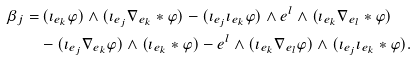<formula> <loc_0><loc_0><loc_500><loc_500>\beta _ { j } = & \, ( \imath _ { e _ { k } } \varphi ) \wedge ( \imath _ { e _ { j } } \nabla _ { e _ { k } } \ast \varphi ) - ( \imath _ { e _ { j } } \imath _ { e _ { k } } \varphi ) \wedge e ^ { l } \wedge ( \imath _ { e _ { k } } \nabla _ { e _ { l } } \ast \varphi ) \\ & - ( \imath _ { e _ { j } } \nabla _ { e _ { k } } \varphi ) \wedge ( \imath _ { e _ { k } } \ast \varphi ) - e ^ { l } \wedge ( \imath _ { e _ { k } } \nabla _ { e _ { l } } \varphi ) \wedge ( \imath _ { e _ { j } } \imath _ { e _ { k } } \ast \varphi ) .</formula> 